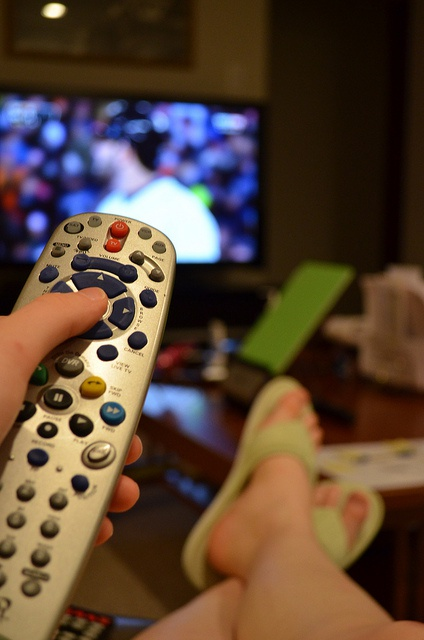Describe the objects in this image and their specific colors. I can see remote in black and tan tones, tv in black, navy, white, and blue tones, people in black, tan, brown, olive, and salmon tones, and people in black, white, lavender, and blue tones in this image. 